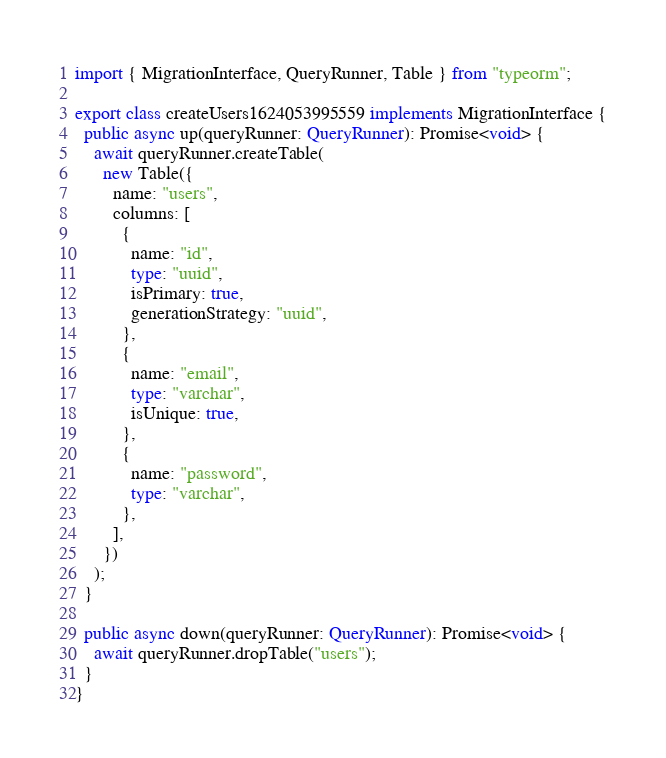Convert code to text. <code><loc_0><loc_0><loc_500><loc_500><_TypeScript_>import { MigrationInterface, QueryRunner, Table } from "typeorm";

export class createUsers1624053995559 implements MigrationInterface {
  public async up(queryRunner: QueryRunner): Promise<void> {
    await queryRunner.createTable(
      new Table({
        name: "users",
        columns: [
          {
            name: "id",
            type: "uuid",
            isPrimary: true,
            generationStrategy: "uuid",
          },
          {
            name: "email",
            type: "varchar",
            isUnique: true,
          },
          {
            name: "password",
            type: "varchar",
          },
        ],
      })
    );
  }

  public async down(queryRunner: QueryRunner): Promise<void> {
    await queryRunner.dropTable("users");
  }
}
</code> 